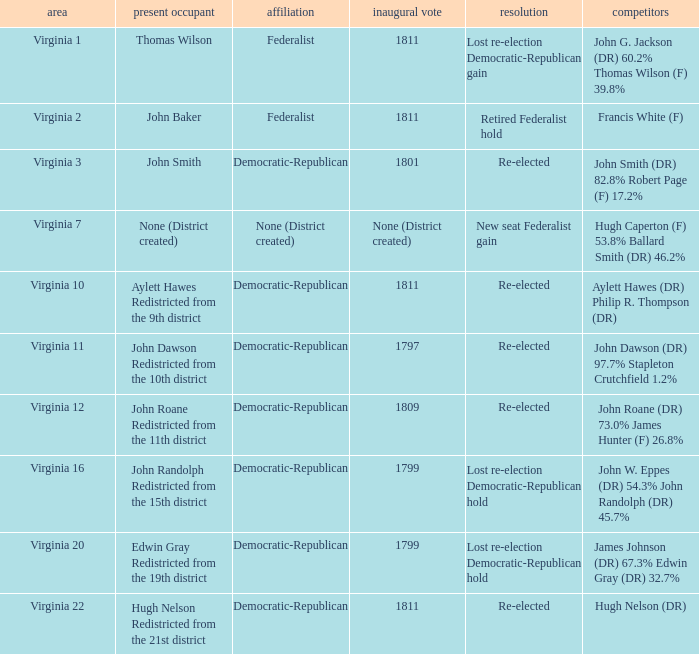Name the distrct for thomas wilson Virginia 1. 